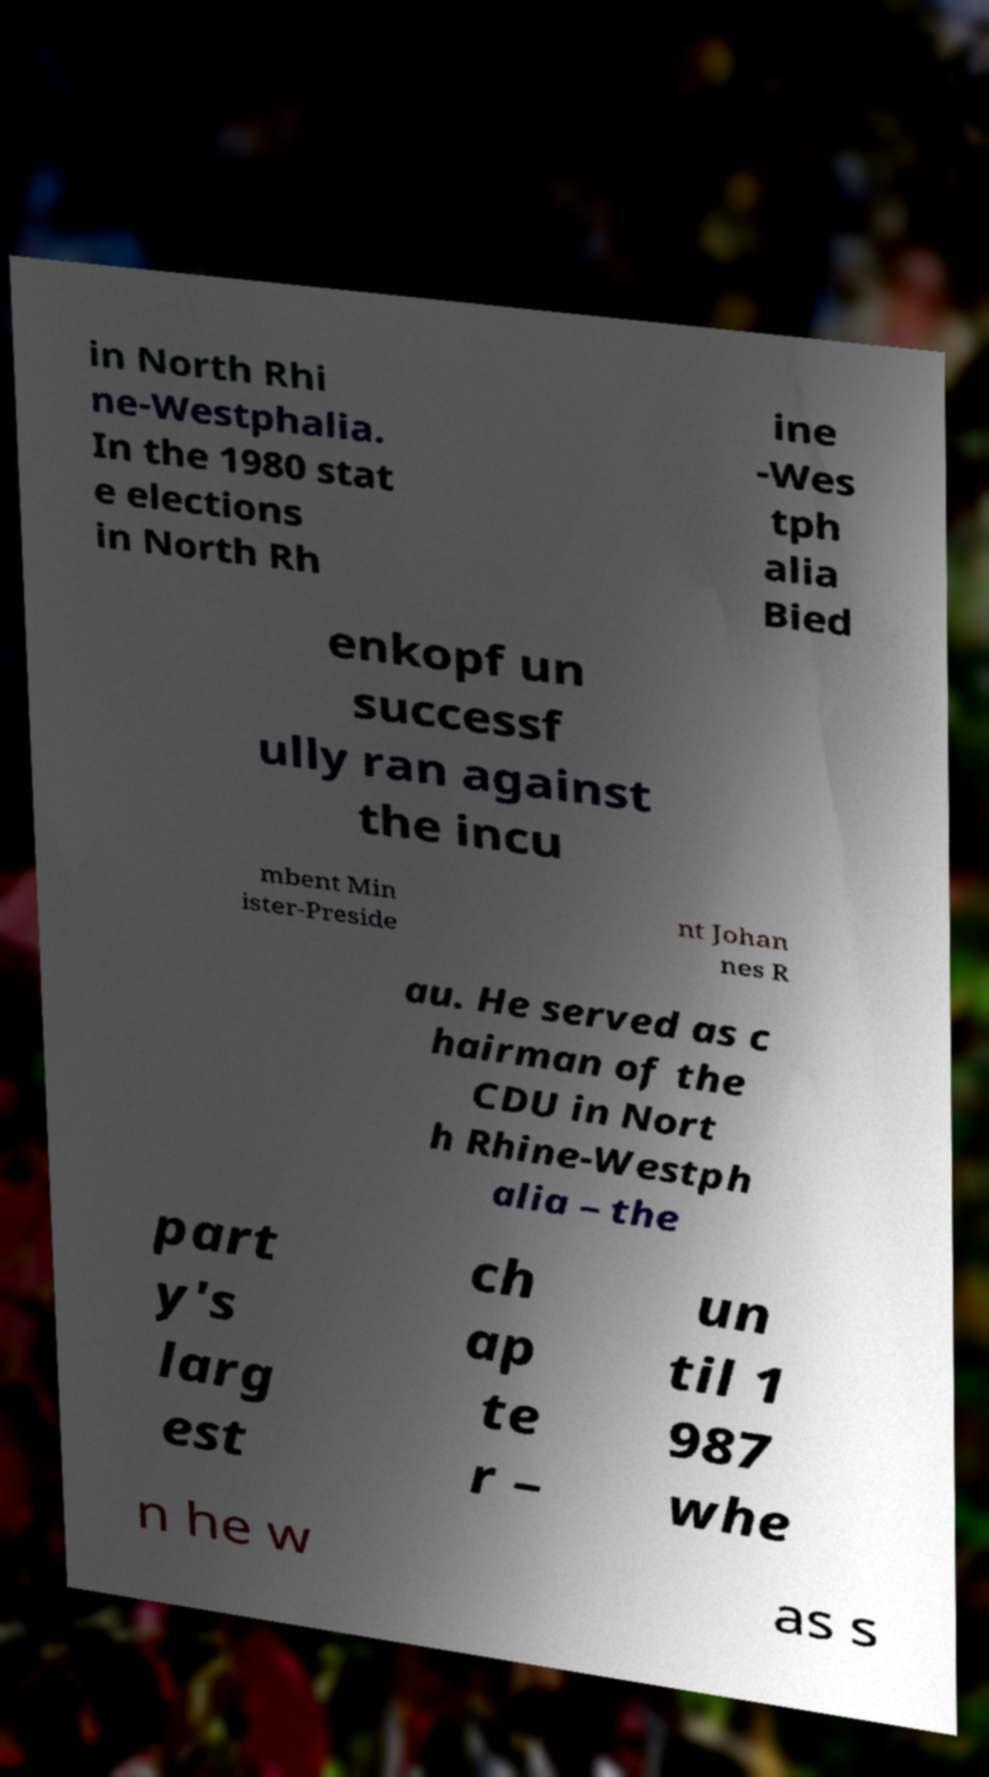Please read and relay the text visible in this image. What does it say? in North Rhi ne-Westphalia. In the 1980 stat e elections in North Rh ine -Wes tph alia Bied enkopf un successf ully ran against the incu mbent Min ister-Preside nt Johan nes R au. He served as c hairman of the CDU in Nort h Rhine-Westph alia – the part y's larg est ch ap te r – un til 1 987 whe n he w as s 